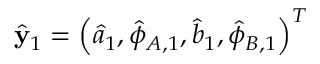Convert formula to latex. <formula><loc_0><loc_0><loc_500><loc_500>\hat { y } _ { 1 } = \left ( \hat { a } _ { 1 } , \hat { \phi } _ { A , 1 } , \hat { b } _ { 1 } , \hat { \phi } _ { B , 1 } \right ) ^ { T }</formula> 